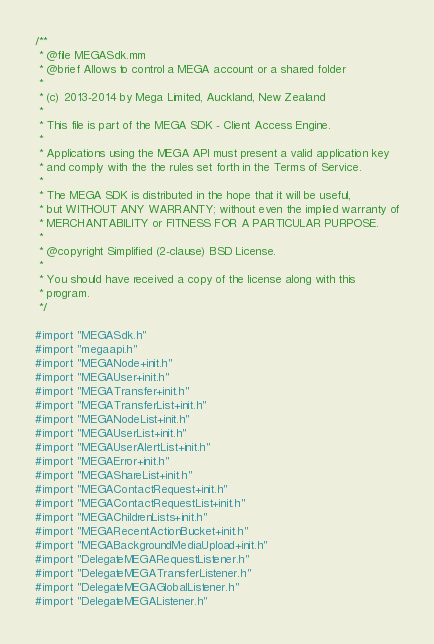Convert code to text. <code><loc_0><loc_0><loc_500><loc_500><_ObjectiveC_>/**
 * @file MEGASdk.mm
 * @brief Allows to control a MEGA account or a shared folder
 *
 * (c) 2013-2014 by Mega Limited, Auckland, New Zealand
 *
 * This file is part of the MEGA SDK - Client Access Engine.
 *
 * Applications using the MEGA API must present a valid application key
 * and comply with the the rules set forth in the Terms of Service.
 *
 * The MEGA SDK is distributed in the hope that it will be useful,
 * but WITHOUT ANY WARRANTY; without even the implied warranty of
 * MERCHANTABILITY or FITNESS FOR A PARTICULAR PURPOSE.
 *
 * @copyright Simplified (2-clause) BSD License.
 *
 * You should have received a copy of the license along with this
 * program.
 */

#import "MEGASdk.h"
#import "megaapi.h"
#import "MEGANode+init.h"
#import "MEGAUser+init.h"
#import "MEGATransfer+init.h"
#import "MEGATransferList+init.h"
#import "MEGANodeList+init.h"
#import "MEGAUserList+init.h"
#import "MEGAUserAlertList+init.h"
#import "MEGAError+init.h"
#import "MEGAShareList+init.h"
#import "MEGAContactRequest+init.h"
#import "MEGAContactRequestList+init.h"
#import "MEGAChildrenLists+init.h"
#import "MEGARecentActionBucket+init.h"
#import "MEGABackgroundMediaUpload+init.h"
#import "DelegateMEGARequestListener.h"
#import "DelegateMEGATransferListener.h"
#import "DelegateMEGAGlobalListener.h"
#import "DelegateMEGAListener.h"</code> 